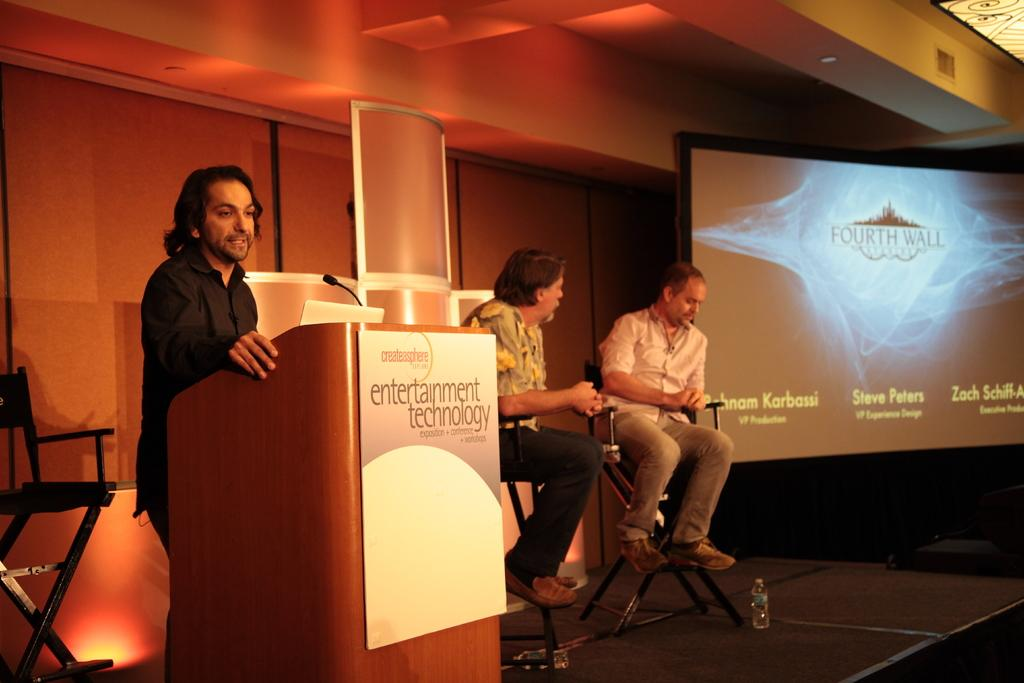<image>
Present a compact description of the photo's key features. A man stands at a podium with the words "Entertainment Technology" next to two men sitting and a large screen with the names of three men on it 